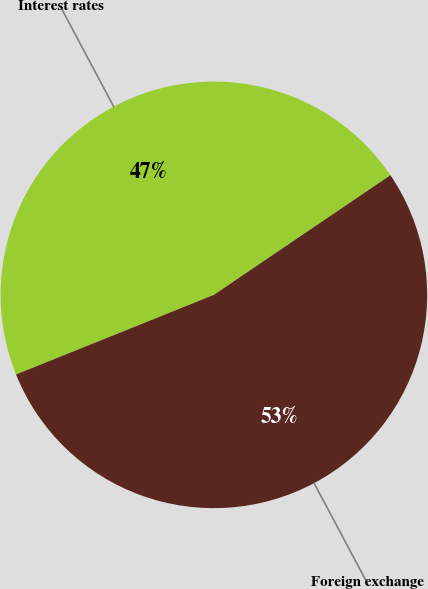<chart> <loc_0><loc_0><loc_500><loc_500><pie_chart><fcel>Interest rates<fcel>Foreign exchange<nl><fcel>46.61%<fcel>53.39%<nl></chart> 